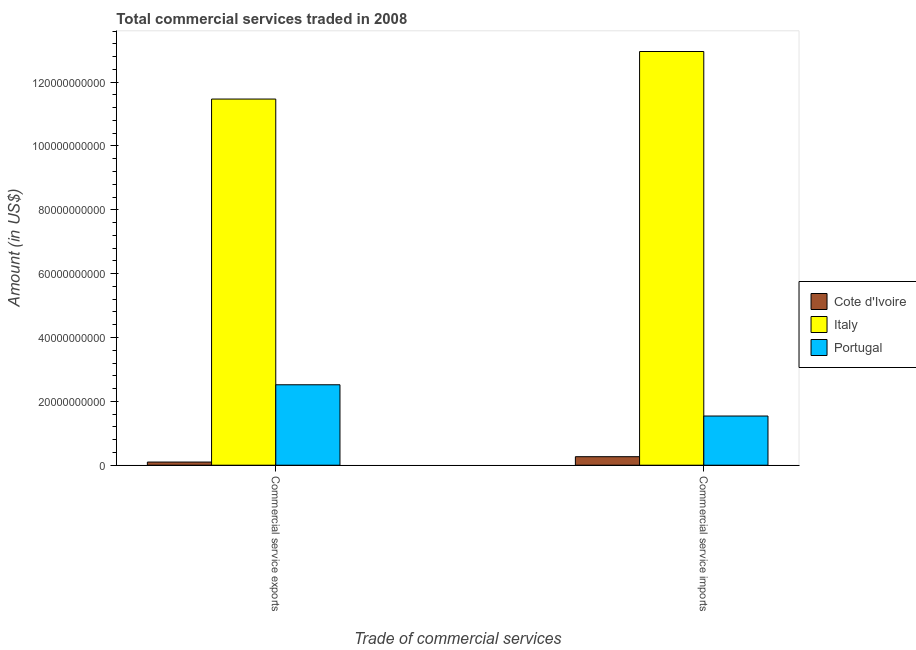Are the number of bars per tick equal to the number of legend labels?
Provide a succinct answer. Yes. Are the number of bars on each tick of the X-axis equal?
Offer a terse response. Yes. How many bars are there on the 2nd tick from the left?
Keep it short and to the point. 3. What is the label of the 1st group of bars from the left?
Ensure brevity in your answer.  Commercial service exports. What is the amount of commercial service imports in Italy?
Give a very brief answer. 1.30e+11. Across all countries, what is the maximum amount of commercial service exports?
Keep it short and to the point. 1.15e+11. Across all countries, what is the minimum amount of commercial service imports?
Ensure brevity in your answer.  2.67e+09. In which country was the amount of commercial service exports maximum?
Your answer should be compact. Italy. In which country was the amount of commercial service exports minimum?
Make the answer very short. Cote d'Ivoire. What is the total amount of commercial service exports in the graph?
Your answer should be compact. 1.41e+11. What is the difference between the amount of commercial service imports in Italy and that in Cote d'Ivoire?
Give a very brief answer. 1.27e+11. What is the difference between the amount of commercial service exports in Portugal and the amount of commercial service imports in Cote d'Ivoire?
Give a very brief answer. 2.25e+1. What is the average amount of commercial service exports per country?
Your answer should be compact. 4.70e+1. What is the difference between the amount of commercial service exports and amount of commercial service imports in Portugal?
Your answer should be very brief. 9.79e+09. What is the ratio of the amount of commercial service exports in Portugal to that in Italy?
Ensure brevity in your answer.  0.22. Is the amount of commercial service exports in Cote d'Ivoire less than that in Italy?
Your response must be concise. Yes. In how many countries, is the amount of commercial service exports greater than the average amount of commercial service exports taken over all countries?
Offer a very short reply. 1. What does the 3rd bar from the left in Commercial service imports represents?
Provide a succinct answer. Portugal. What does the 2nd bar from the right in Commercial service exports represents?
Provide a short and direct response. Italy. Are the values on the major ticks of Y-axis written in scientific E-notation?
Ensure brevity in your answer.  No. Does the graph contain any zero values?
Give a very brief answer. No. How many legend labels are there?
Keep it short and to the point. 3. What is the title of the graph?
Offer a very short reply. Total commercial services traded in 2008. What is the label or title of the X-axis?
Your answer should be very brief. Trade of commercial services. What is the Amount (in US$) of Cote d'Ivoire in Commercial service exports?
Provide a short and direct response. 9.87e+08. What is the Amount (in US$) in Italy in Commercial service exports?
Make the answer very short. 1.15e+11. What is the Amount (in US$) of Portugal in Commercial service exports?
Give a very brief answer. 2.52e+1. What is the Amount (in US$) in Cote d'Ivoire in Commercial service imports?
Ensure brevity in your answer.  2.67e+09. What is the Amount (in US$) in Italy in Commercial service imports?
Your answer should be very brief. 1.30e+11. What is the Amount (in US$) of Portugal in Commercial service imports?
Your answer should be compact. 1.54e+1. Across all Trade of commercial services, what is the maximum Amount (in US$) in Cote d'Ivoire?
Ensure brevity in your answer.  2.67e+09. Across all Trade of commercial services, what is the maximum Amount (in US$) in Italy?
Your response must be concise. 1.30e+11. Across all Trade of commercial services, what is the maximum Amount (in US$) in Portugal?
Ensure brevity in your answer.  2.52e+1. Across all Trade of commercial services, what is the minimum Amount (in US$) of Cote d'Ivoire?
Offer a terse response. 9.87e+08. Across all Trade of commercial services, what is the minimum Amount (in US$) of Italy?
Offer a terse response. 1.15e+11. Across all Trade of commercial services, what is the minimum Amount (in US$) of Portugal?
Offer a terse response. 1.54e+1. What is the total Amount (in US$) in Cote d'Ivoire in the graph?
Offer a terse response. 3.65e+09. What is the total Amount (in US$) of Italy in the graph?
Provide a succinct answer. 2.44e+11. What is the total Amount (in US$) in Portugal in the graph?
Your answer should be compact. 4.06e+1. What is the difference between the Amount (in US$) in Cote d'Ivoire in Commercial service exports and that in Commercial service imports?
Keep it short and to the point. -1.68e+09. What is the difference between the Amount (in US$) of Italy in Commercial service exports and that in Commercial service imports?
Your answer should be very brief. -1.49e+1. What is the difference between the Amount (in US$) in Portugal in Commercial service exports and that in Commercial service imports?
Offer a very short reply. 9.79e+09. What is the difference between the Amount (in US$) of Cote d'Ivoire in Commercial service exports and the Amount (in US$) of Italy in Commercial service imports?
Your response must be concise. -1.29e+11. What is the difference between the Amount (in US$) in Cote d'Ivoire in Commercial service exports and the Amount (in US$) in Portugal in Commercial service imports?
Provide a succinct answer. -1.44e+1. What is the difference between the Amount (in US$) of Italy in Commercial service exports and the Amount (in US$) of Portugal in Commercial service imports?
Ensure brevity in your answer.  9.93e+1. What is the average Amount (in US$) in Cote d'Ivoire per Trade of commercial services?
Provide a succinct answer. 1.83e+09. What is the average Amount (in US$) in Italy per Trade of commercial services?
Your answer should be compact. 1.22e+11. What is the average Amount (in US$) in Portugal per Trade of commercial services?
Ensure brevity in your answer.  2.03e+1. What is the difference between the Amount (in US$) of Cote d'Ivoire and Amount (in US$) of Italy in Commercial service exports?
Provide a short and direct response. -1.14e+11. What is the difference between the Amount (in US$) of Cote d'Ivoire and Amount (in US$) of Portugal in Commercial service exports?
Keep it short and to the point. -2.42e+1. What is the difference between the Amount (in US$) of Italy and Amount (in US$) of Portugal in Commercial service exports?
Your answer should be compact. 8.95e+1. What is the difference between the Amount (in US$) in Cote d'Ivoire and Amount (in US$) in Italy in Commercial service imports?
Your answer should be compact. -1.27e+11. What is the difference between the Amount (in US$) of Cote d'Ivoire and Amount (in US$) of Portugal in Commercial service imports?
Your answer should be very brief. -1.27e+1. What is the difference between the Amount (in US$) in Italy and Amount (in US$) in Portugal in Commercial service imports?
Give a very brief answer. 1.14e+11. What is the ratio of the Amount (in US$) of Cote d'Ivoire in Commercial service exports to that in Commercial service imports?
Give a very brief answer. 0.37. What is the ratio of the Amount (in US$) in Italy in Commercial service exports to that in Commercial service imports?
Your answer should be very brief. 0.89. What is the ratio of the Amount (in US$) in Portugal in Commercial service exports to that in Commercial service imports?
Provide a succinct answer. 1.64. What is the difference between the highest and the second highest Amount (in US$) in Cote d'Ivoire?
Offer a terse response. 1.68e+09. What is the difference between the highest and the second highest Amount (in US$) in Italy?
Keep it short and to the point. 1.49e+1. What is the difference between the highest and the second highest Amount (in US$) in Portugal?
Offer a very short reply. 9.79e+09. What is the difference between the highest and the lowest Amount (in US$) in Cote d'Ivoire?
Your answer should be compact. 1.68e+09. What is the difference between the highest and the lowest Amount (in US$) of Italy?
Keep it short and to the point. 1.49e+1. What is the difference between the highest and the lowest Amount (in US$) of Portugal?
Give a very brief answer. 9.79e+09. 